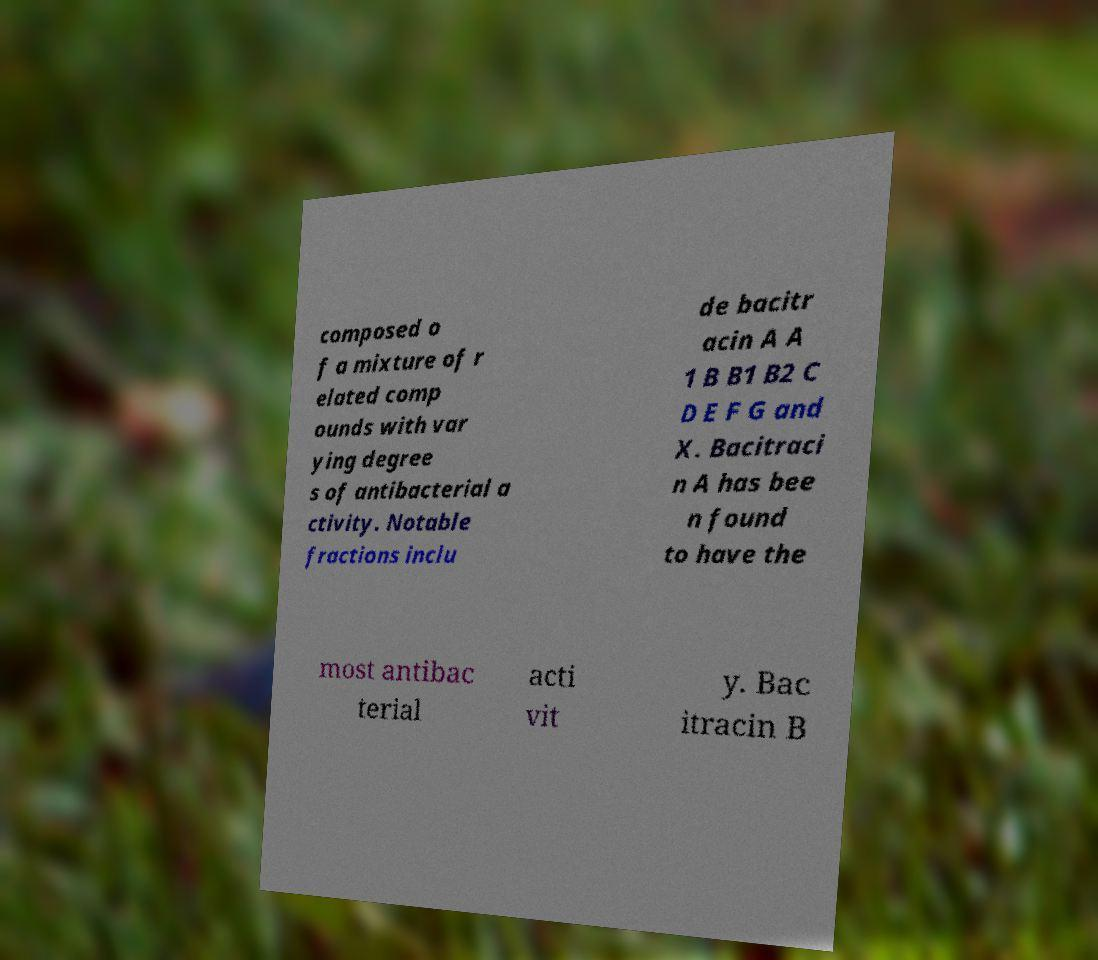Can you accurately transcribe the text from the provided image for me? composed o f a mixture of r elated comp ounds with var ying degree s of antibacterial a ctivity. Notable fractions inclu de bacitr acin A A 1 B B1 B2 C D E F G and X. Bacitraci n A has bee n found to have the most antibac terial acti vit y. Bac itracin B 